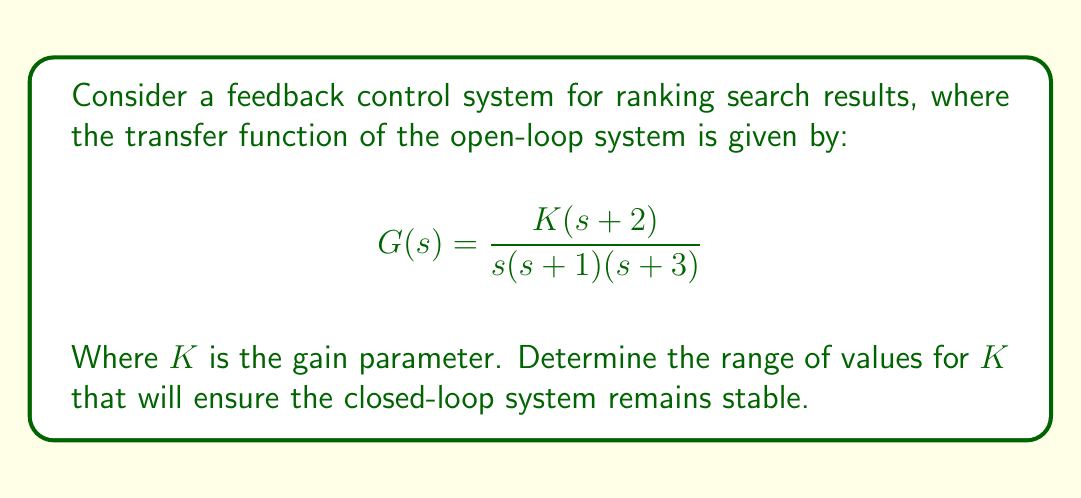Teach me how to tackle this problem. To analyze the stability of this feedback control system, we'll use the Routh-Hurwitz stability criterion. This method is particularly relevant for information retrieval systems, as it allows us to determine the stability of the ranking algorithm without solving for the roots of the characteristic equation.

Steps:

1) First, we need to find the characteristic equation of the closed-loop system. The closed-loop transfer function is:

   $$T(s) = \frac{G(s)}{1+G(s)} = \frac{K(s+2)}{s(s+1)(s+3) + K(s+2)}$$

2) The characteristic equation is the denominator of T(s) set to zero:

   $$s(s+1)(s+3) + K(s+2) = 0$$

3) Expanding this equation:

   $$s^3 + 4s^2 + 3s + K(s+2) = 0$$
   $$s^3 + 4s^2 + (3+K)s + 2K = 0$$

4) Now, we can construct the Routh array:

   $$\begin{array}{c|cc}
   s^3 & 1 & 3+K \\
   s^2 & 4 & 2K \\
   s^1 & \frac{12+3K-2K}{4} & 0 \\
   s^0 & 2K & 0
   \end{array}$$

5) For the system to be stable, all elements in the first column of the Routh array must be positive. From this, we can derive the following conditions:

   $1 > 0$ (always true)
   $4 > 0$ (always true)
   $\frac{12+3K-2K}{4} > 0$
   $2K > 0$

6) From the last condition, we know that $K > 0$.

7) From the third condition:

   $$\frac{12+3K-2K}{4} > 0$$
   $$12+K > 0$$
   $$K > -12$$

8) Combining the conditions from steps 6 and 7, we get:

   $$K > 0$$

Therefore, the system is stable for all positive values of K.
Answer: The closed-loop system is stable for all $K > 0$. 